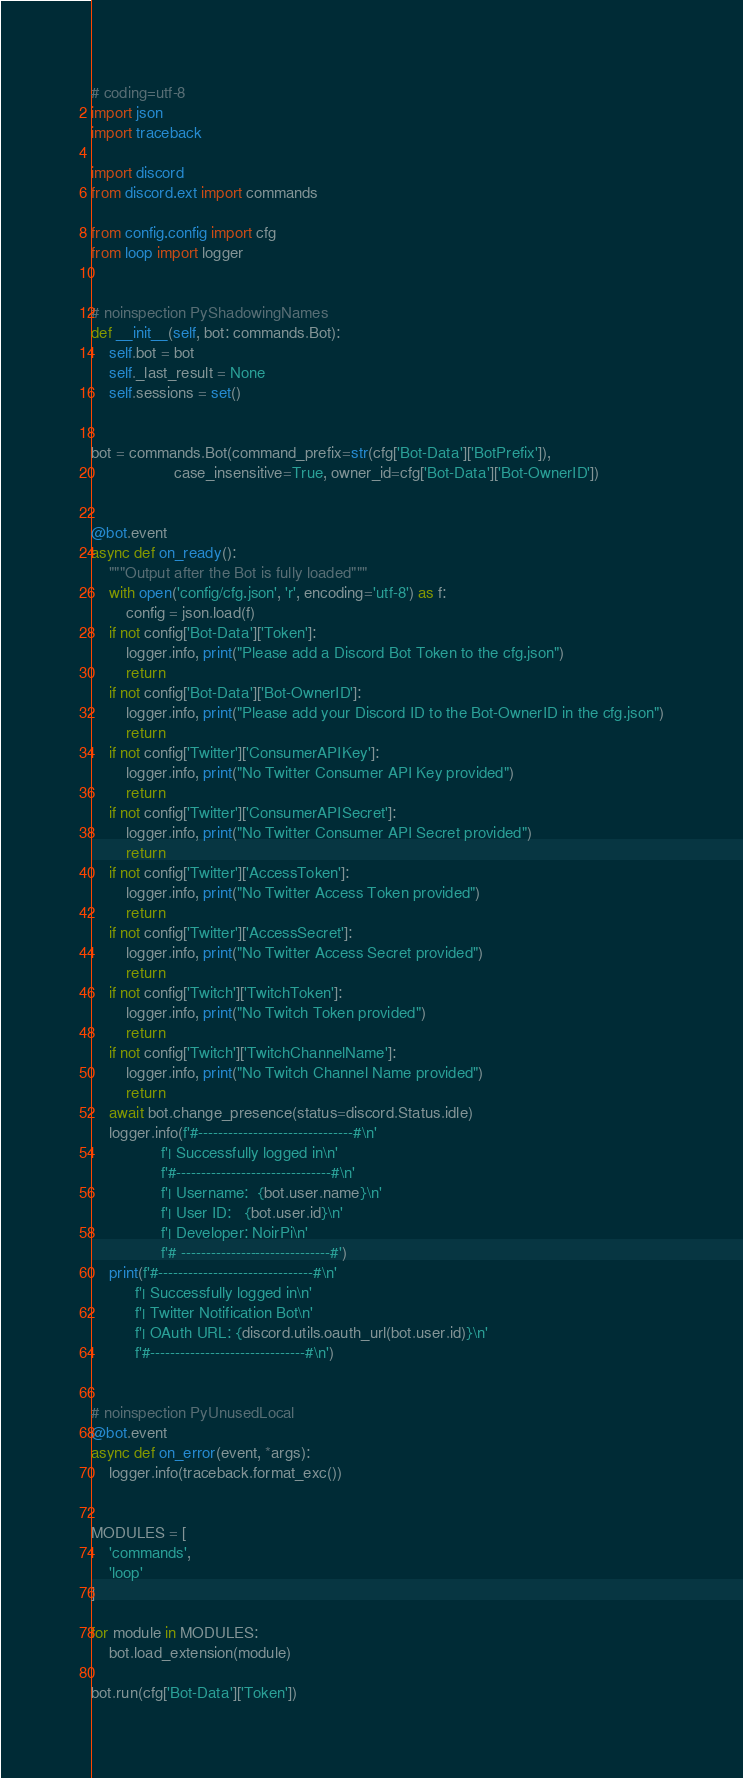Convert code to text. <code><loc_0><loc_0><loc_500><loc_500><_Python_># coding=utf-8
import json
import traceback

import discord
from discord.ext import commands

from config.config import cfg
from loop import logger


# noinspection PyShadowingNames
def __init__(self, bot: commands.Bot):
    self.bot = bot
    self._last_result = None
    self.sessions = set()


bot = commands.Bot(command_prefix=str(cfg['Bot-Data']['BotPrefix']),
                   case_insensitive=True, owner_id=cfg['Bot-Data']['Bot-OwnerID'])


@bot.event
async def on_ready():
    """Output after the Bot is fully loaded"""
    with open('config/cfg.json', 'r', encoding='utf-8') as f:
        config = json.load(f)
    if not config['Bot-Data']['Token']:
        logger.info, print("Please add a Discord Bot Token to the cfg.json")
        return
    if not config['Bot-Data']['Bot-OwnerID']:
        logger.info, print("Please add your Discord ID to the Bot-OwnerID in the cfg.json")
        return
    if not config['Twitter']['ConsumerAPIKey']:
        logger.info, print("No Twitter Consumer API Key provided")
        return
    if not config['Twitter']['ConsumerAPISecret']:
        logger.info, print("No Twitter Consumer API Secret provided")
        return
    if not config['Twitter']['AccessToken']:
        logger.info, print("No Twitter Access Token provided")
        return
    if not config['Twitter']['AccessSecret']:
        logger.info, print("No Twitter Access Secret provided")
        return
    if not config['Twitch']['TwitchToken']:
        logger.info, print("No Twitch Token provided")
        return
    if not config['Twitch']['TwitchChannelName']:
        logger.info, print("No Twitch Channel Name provided")
        return
    await bot.change_presence(status=discord.Status.idle)
    logger.info(f'#-------------------------------#\n'
                f'| Successfully logged in\n'
                f'#-------------------------------#\n'
                f'| Username:  {bot.user.name}\n'
                f'| User ID:   {bot.user.id}\n'
                f'| Developer: NoirPi\n'
                f'# ------------------------------#')
    print(f'#-------------------------------#\n'
          f'| Successfully logged in\n'
          f'| Twitter Notification Bot\n'
          f'| OAuth URL: {discord.utils.oauth_url(bot.user.id)}\n'
          f'#-------------------------------#\n')


# noinspection PyUnusedLocal
@bot.event
async def on_error(event, *args):
    logger.info(traceback.format_exc())


MODULES = [
    'commands',
    'loop'
]

for module in MODULES:
    bot.load_extension(module)

bot.run(cfg['Bot-Data']['Token'])
</code> 